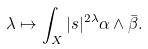<formula> <loc_0><loc_0><loc_500><loc_500>\lambda \mapsto \int _ { X } | s | ^ { 2 \lambda } \alpha \wedge \bar { \beta } .</formula> 